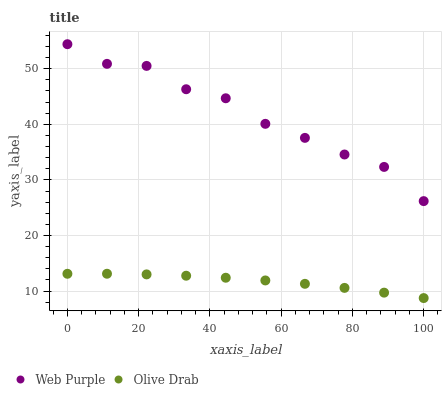Does Olive Drab have the minimum area under the curve?
Answer yes or no. Yes. Does Web Purple have the maximum area under the curve?
Answer yes or no. Yes. Does Olive Drab have the maximum area under the curve?
Answer yes or no. No. Is Olive Drab the smoothest?
Answer yes or no. Yes. Is Web Purple the roughest?
Answer yes or no. Yes. Is Olive Drab the roughest?
Answer yes or no. No. Does Olive Drab have the lowest value?
Answer yes or no. Yes. Does Web Purple have the highest value?
Answer yes or no. Yes. Does Olive Drab have the highest value?
Answer yes or no. No. Is Olive Drab less than Web Purple?
Answer yes or no. Yes. Is Web Purple greater than Olive Drab?
Answer yes or no. Yes. Does Olive Drab intersect Web Purple?
Answer yes or no. No. 